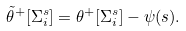<formula> <loc_0><loc_0><loc_500><loc_500>\tilde { \theta } ^ { + } [ \Sigma _ { i } ^ { s } ] = \theta ^ { + } [ \Sigma _ { i } ^ { s } ] - \psi ( s ) .</formula> 